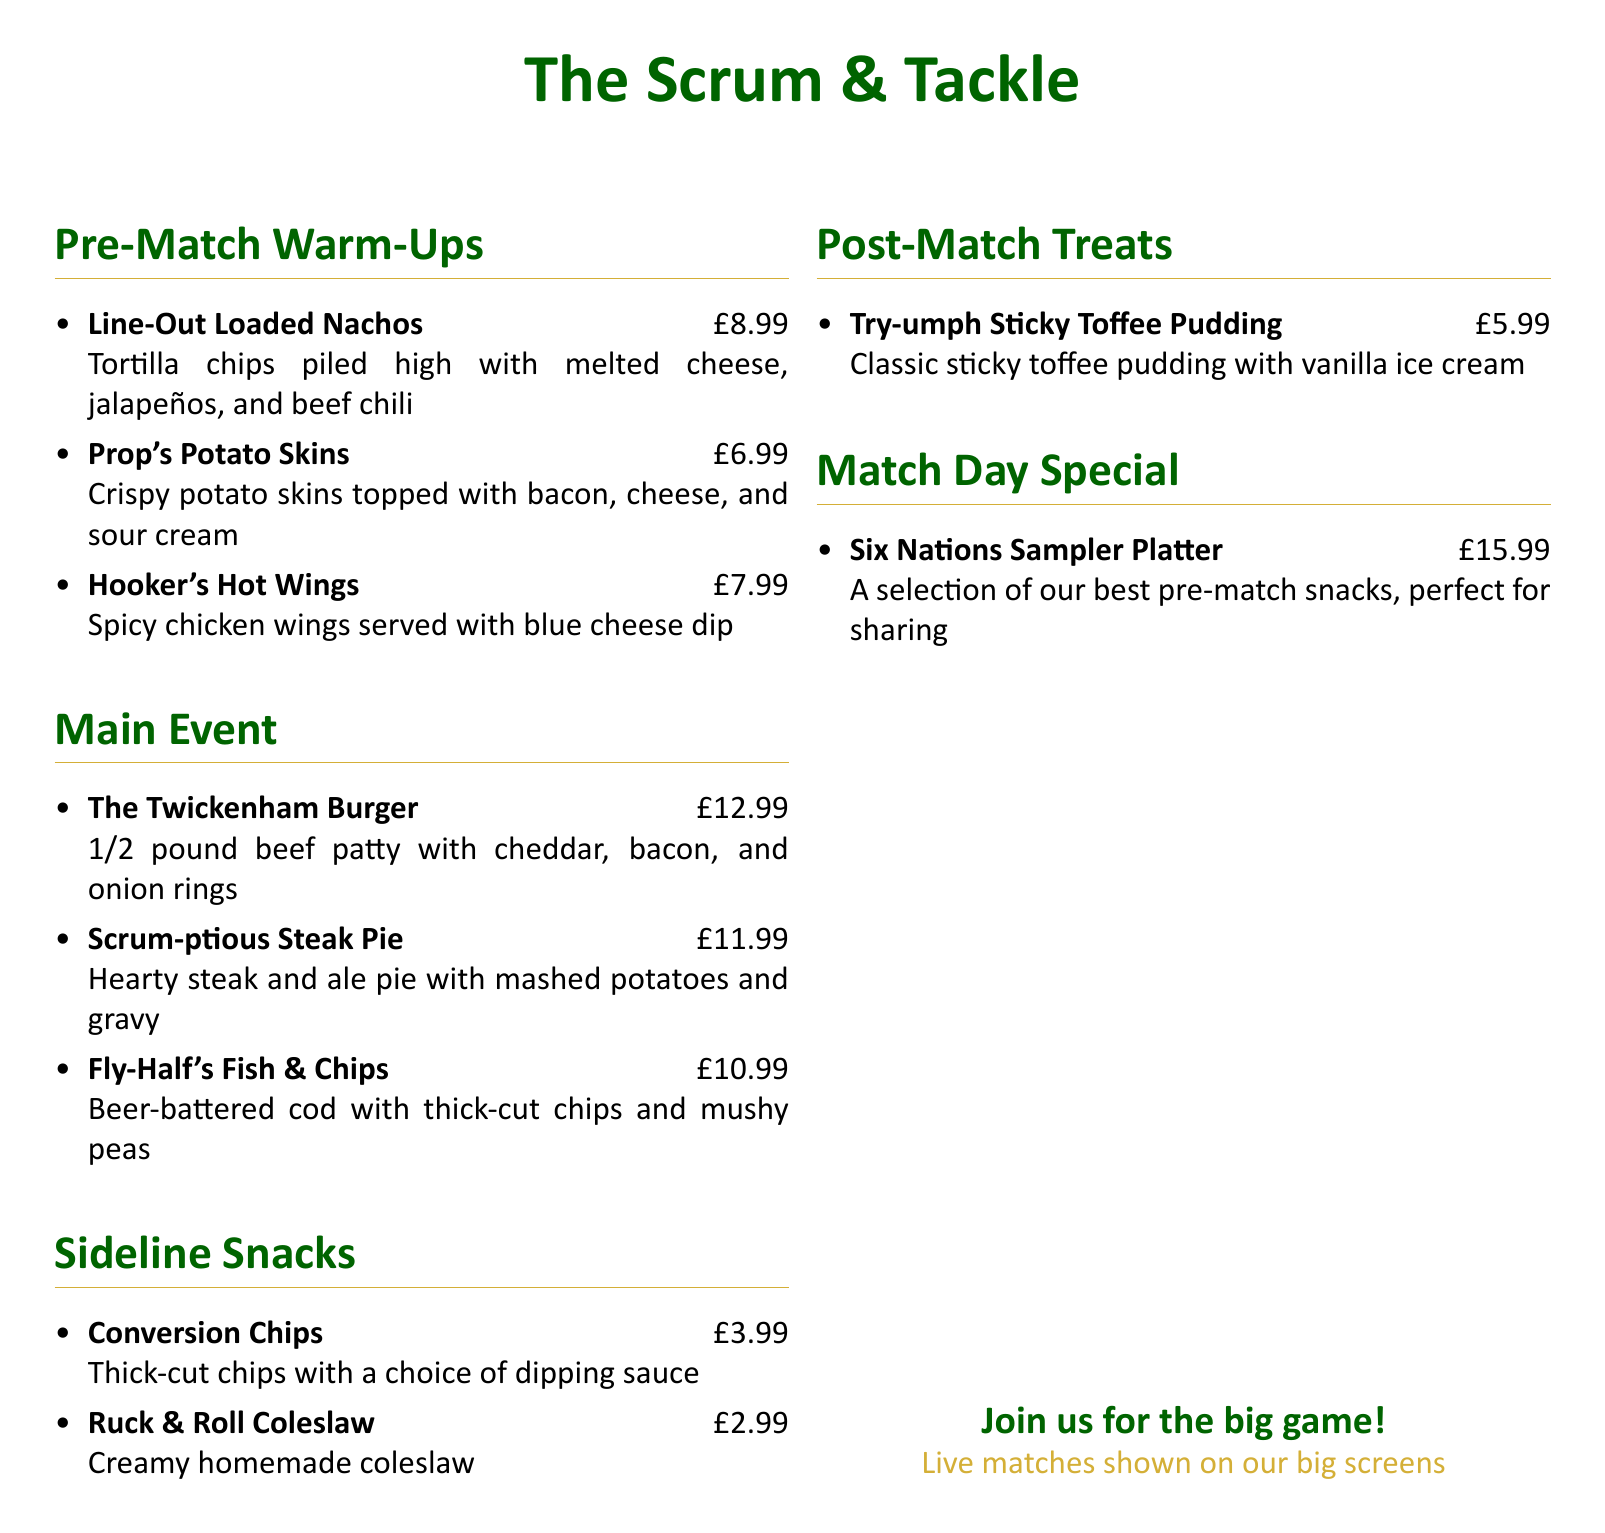What is the name of the pub? The document presents a menu for "The Scrum & Tackle."
Answer: The Scrum & Tackle How much do the Hooker's Hot Wings cost? The price of the Hooker's Hot Wings is listed on the menu.
Answer: £7.99 What is included in the Six Nations Sampler Platter? The platter features a selection of the best pre-match snacks.
Answer: A selection of our best pre-match snacks How many pre-match warm-up snacks are listed in the document? The menu includes three pre-match warm-up snacks.
Answer: 3 What is the main ingredient in the Fly-Half's Fish & Chips? The main ingredient in this dish is beer-battered cod.
Answer: Beer-battered cod What type of sauce do the Conversion Chips come with? The document states that Conversion Chips come with a choice of dipping sauce.
Answer: A choice of dipping sauce What dessert is available on the menu? The menu lists one dessert, which is "Try-umph Sticky Toffee Pudding."
Answer: Try-umph Sticky Toffee Pudding How many sections are there in the menu? The menu is divided into five sections: Pre-Match Warm-Ups, Main Event, Sideline Snacks, Post-Match Treats, and Match Day Special.
Answer: 5 What does the menu say about live matches? The menu mentions that live matches are shown on big screens.
Answer: Live matches shown on our big screens 